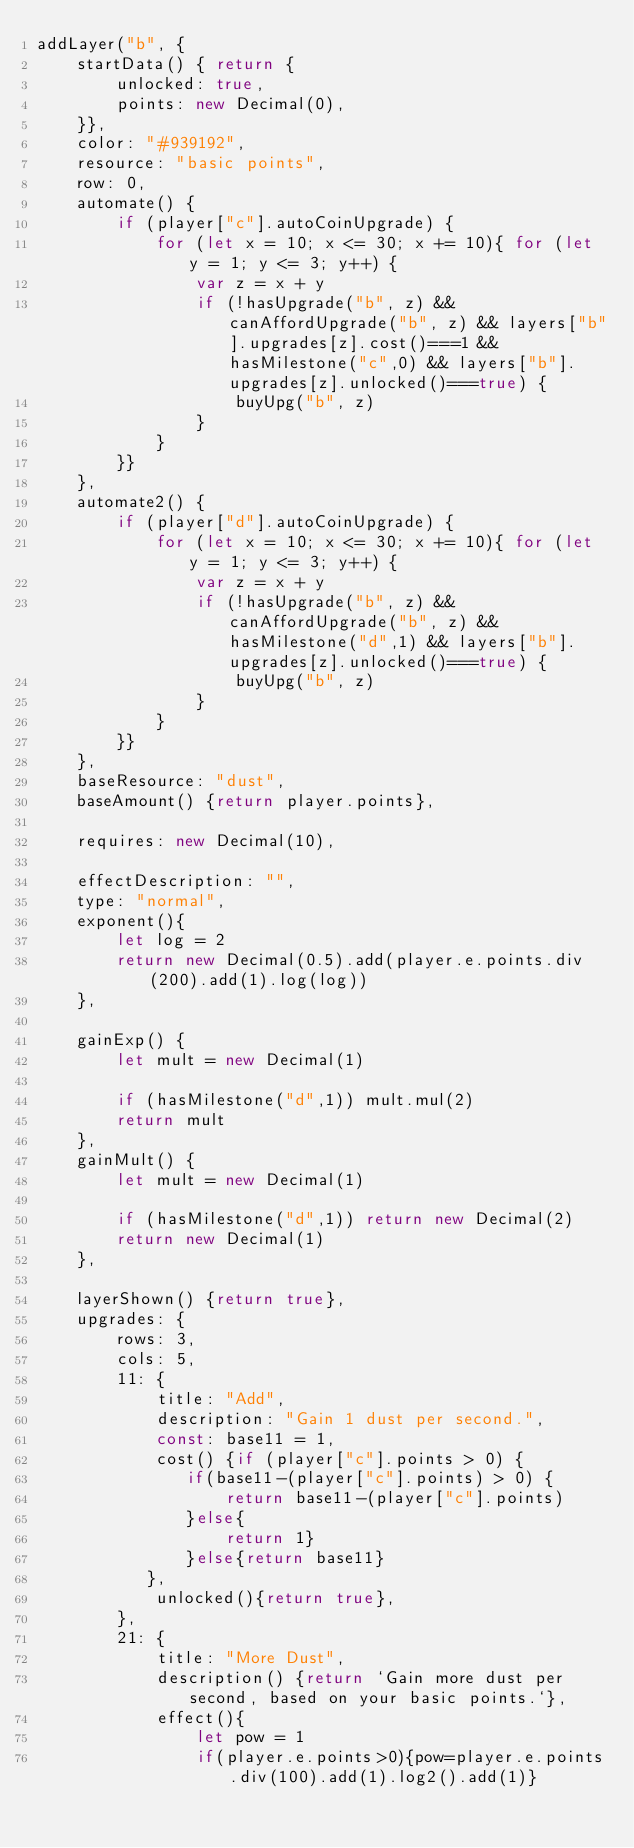<code> <loc_0><loc_0><loc_500><loc_500><_JavaScript_>addLayer("b", {
    startData() { return {
        unlocked: true,
        points: new Decimal(0),
    }},
    color: "#939192", 
    resource: "basic points",            
    row: 0,                                 
    automate() {
        if (player["c"].autoCoinUpgrade) {
            for (let x = 10; x <= 30; x += 10){ for (let y = 1; y <= 3; y++) {
                var z = x + y
                if (!hasUpgrade("b", z) && canAffordUpgrade("b", z) && layers["b"].upgrades[z].cost()===1 && hasMilestone("c",0) && layers["b"].upgrades[z].unlocked()===true) {
                    buyUpg("b", z)
                }
            }
        }}
    },
    automate2() {
        if (player["d"].autoCoinUpgrade) {
            for (let x = 10; x <= 30; x += 10){ for (let y = 1; y <= 3; y++) {
                var z = x + y
                if (!hasUpgrade("b", z) && canAffordUpgrade("b", z) && hasMilestone("d",1) && layers["b"].upgrades[z].unlocked()===true) {
                    buyUpg("b", z)
                }
            }
        }}
    },
    baseResource: "dust",                 
    baseAmount() {return player.points},    

    requires: new Decimal(10),            
                                            
    effectDescription: "",
    type: "normal",                         
    exponent(){
        let log = 2
        return new Decimal(0.5).add(player.e.points.div(200).add(1).log(log))
    },                          

    gainExp() {       
        let mult = new Decimal(1)

        if (hasMilestone("d",1)) mult.mul(2)
        return mult              
    },
    gainMult() {       
        let mult = new Decimal(1)

        if (hasMilestone("d",1)) return new Decimal(2)
        return new Decimal(1)          
    },

    layerShown() {return true},  
    upgrades: {
        rows: 3,
        cols: 5,
        11: {
            title: "Add",
            description: "Gain 1 dust per second.",
            const: base11 = 1,
            cost() {if (player["c"].points > 0) {
               if(base11-(player["c"].points) > 0) {
                   return base11-(player["c"].points)
               }else{
                   return 1}
               }else{return base11}
           },
            unlocked(){return true},
        },
        21: {
            title: "More Dust",
            description() {return `Gain more dust per second, based on your basic points.`},
            effect(){
                let pow = 1
                if(player.e.points>0){pow=player.e.points.div(100).add(1).log2().add(1)}</code> 